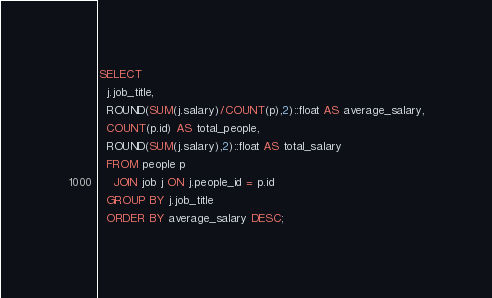Convert code to text. <code><loc_0><loc_0><loc_500><loc_500><_SQL_>SELECT 
  j.job_title,
  ROUND(SUM(j.salary)/COUNT(p),2)::float AS average_salary,
  COUNT(p.id) AS total_people,
  ROUND(SUM(j.salary),2)::float AS total_salary
  FROM people p
    JOIN job j ON j.people_id = p.id
  GROUP BY j.job_title
  ORDER BY average_salary DESC;</code> 